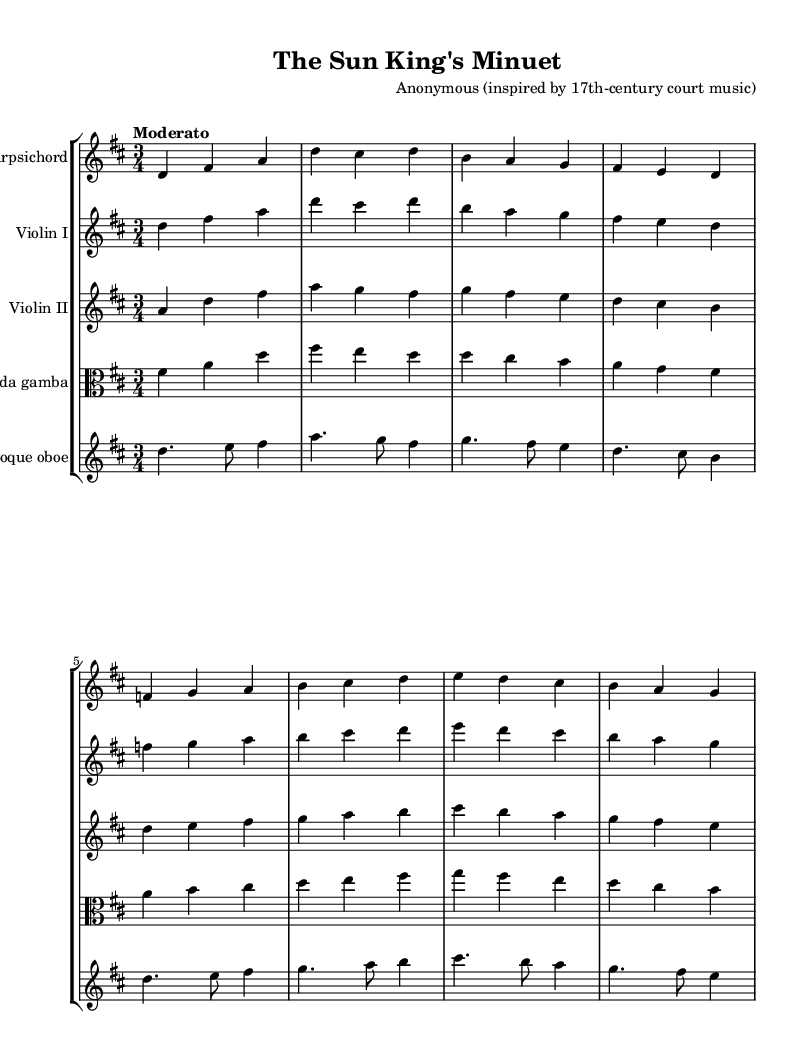What is the key signature of this composition? The key signature indicates that this piece is in the key of D major, which has two sharps (F# and C#). This can be observed at the beginning of the staff lines before the first note of the piece.
Answer: D major What is the time signature of the piece? The time signature is shown at the beginning of the score as 3/4, which means there are three quarter-note beats in each measure. This is evident in the notation at the start of the music.
Answer: 3/4 What is the tempo marking of this composition? The tempo marking is indicated as "Moderato" at the beginning of the piece, which describes the speed of the music as moderate. This marking is included in the header section of the score.
Answer: Moderato How many instruments are indicated in the score? The score shows five different instruments: Harpsichord, Violin I, Violin II, Viola da gamba, and Baroque oboe. Each instrument has its own staff, which is clearly labeled at the beginning of each section.
Answer: Five Which instrument plays the highest notes in this score? The highest notes are played by the Baroque oboe, as indicated by the notation on the oboe staff, which consistently features higher pitches in comparison to the other instruments.
Answer: Baroque oboe What is the dynamic marking for the violins in this piece? There are no specific dynamic markings noted in the provided score for the violins, suggesting that the performers may interpret the dynamics based on style and context. The absence of markings indicates the lack of specific dynamics.
Answer: None How does the structure of this composition reflect courtly music traditions? The piece features a regular structure and balanced phrases, which are characteristic of Baroque compositions intended for courtly performance, reflecting the elegance and order relevant to the aristocratic society of the 17th century. This can be analyzed through the consistent phrasing and instrumental interplay present throughout the score.
Answer: Reflects courtly music traditions 